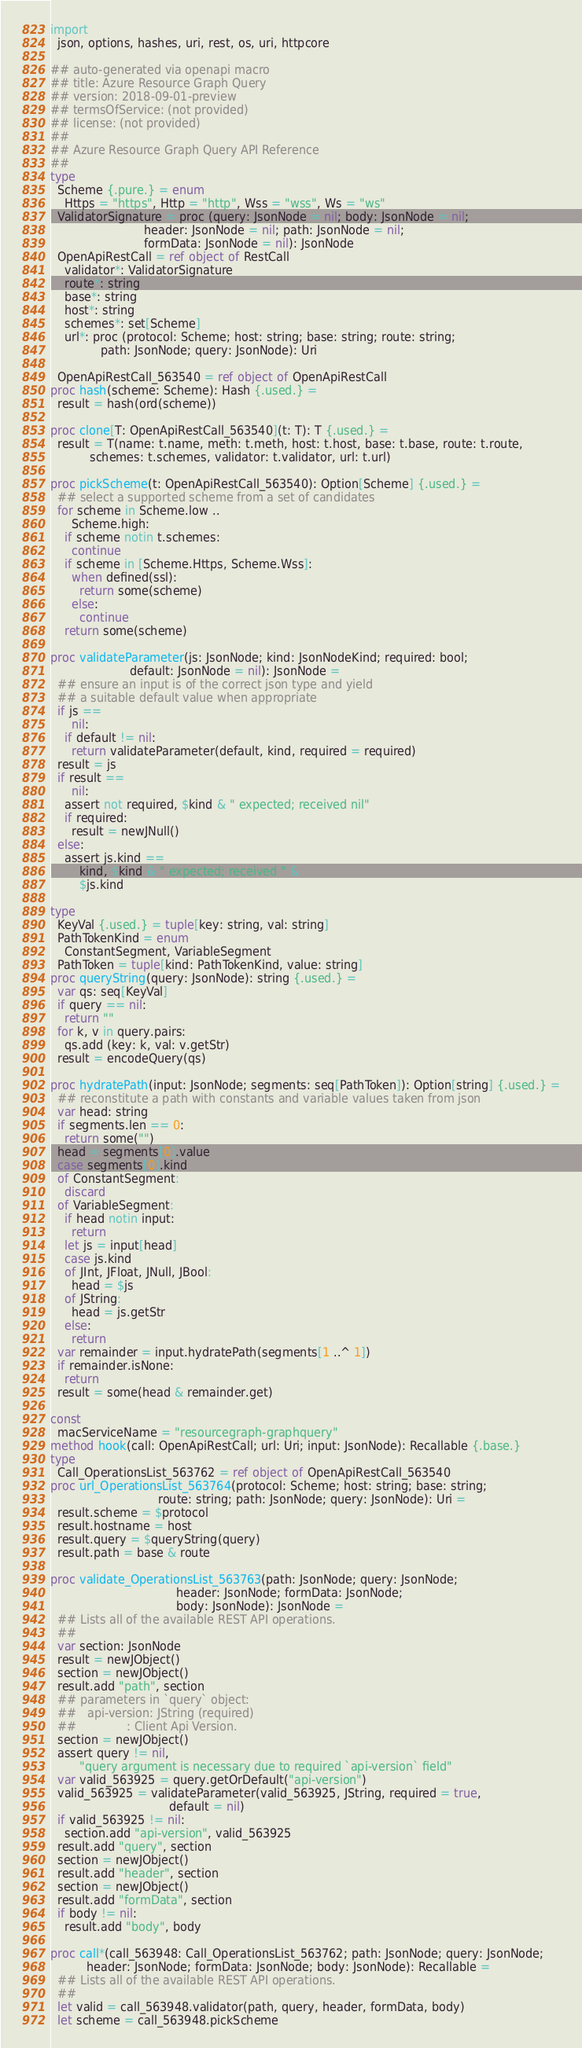<code> <loc_0><loc_0><loc_500><loc_500><_Nim_>
import
  json, options, hashes, uri, rest, os, uri, httpcore

## auto-generated via openapi macro
## title: Azure Resource Graph Query
## version: 2018-09-01-preview
## termsOfService: (not provided)
## license: (not provided)
## 
## Azure Resource Graph Query API Reference
## 
type
  Scheme {.pure.} = enum
    Https = "https", Http = "http", Wss = "wss", Ws = "ws"
  ValidatorSignature = proc (query: JsonNode = nil; body: JsonNode = nil;
                          header: JsonNode = nil; path: JsonNode = nil;
                          formData: JsonNode = nil): JsonNode
  OpenApiRestCall = ref object of RestCall
    validator*: ValidatorSignature
    route*: string
    base*: string
    host*: string
    schemes*: set[Scheme]
    url*: proc (protocol: Scheme; host: string; base: string; route: string;
              path: JsonNode; query: JsonNode): Uri

  OpenApiRestCall_563540 = ref object of OpenApiRestCall
proc hash(scheme: Scheme): Hash {.used.} =
  result = hash(ord(scheme))

proc clone[T: OpenApiRestCall_563540](t: T): T {.used.} =
  result = T(name: t.name, meth: t.meth, host: t.host, base: t.base, route: t.route,
           schemes: t.schemes, validator: t.validator, url: t.url)

proc pickScheme(t: OpenApiRestCall_563540): Option[Scheme] {.used.} =
  ## select a supported scheme from a set of candidates
  for scheme in Scheme.low ..
      Scheme.high:
    if scheme notin t.schemes:
      continue
    if scheme in [Scheme.Https, Scheme.Wss]:
      when defined(ssl):
        return some(scheme)
      else:
        continue
    return some(scheme)

proc validateParameter(js: JsonNode; kind: JsonNodeKind; required: bool;
                      default: JsonNode = nil): JsonNode =
  ## ensure an input is of the correct json type and yield
  ## a suitable default value when appropriate
  if js ==
      nil:
    if default != nil:
      return validateParameter(default, kind, required = required)
  result = js
  if result ==
      nil:
    assert not required, $kind & " expected; received nil"
    if required:
      result = newJNull()
  else:
    assert js.kind ==
        kind, $kind & " expected; received " &
        $js.kind

type
  KeyVal {.used.} = tuple[key: string, val: string]
  PathTokenKind = enum
    ConstantSegment, VariableSegment
  PathToken = tuple[kind: PathTokenKind, value: string]
proc queryString(query: JsonNode): string {.used.} =
  var qs: seq[KeyVal]
  if query == nil:
    return ""
  for k, v in query.pairs:
    qs.add (key: k, val: v.getStr)
  result = encodeQuery(qs)

proc hydratePath(input: JsonNode; segments: seq[PathToken]): Option[string] {.used.} =
  ## reconstitute a path with constants and variable values taken from json
  var head: string
  if segments.len == 0:
    return some("")
  head = segments[0].value
  case segments[0].kind
  of ConstantSegment:
    discard
  of VariableSegment:
    if head notin input:
      return
    let js = input[head]
    case js.kind
    of JInt, JFloat, JNull, JBool:
      head = $js
    of JString:
      head = js.getStr
    else:
      return
  var remainder = input.hydratePath(segments[1 ..^ 1])
  if remainder.isNone:
    return
  result = some(head & remainder.get)

const
  macServiceName = "resourcegraph-graphquery"
method hook(call: OpenApiRestCall; url: Uri; input: JsonNode): Recallable {.base.}
type
  Call_OperationsList_563762 = ref object of OpenApiRestCall_563540
proc url_OperationsList_563764(protocol: Scheme; host: string; base: string;
                              route: string; path: JsonNode; query: JsonNode): Uri =
  result.scheme = $protocol
  result.hostname = host
  result.query = $queryString(query)
  result.path = base & route

proc validate_OperationsList_563763(path: JsonNode; query: JsonNode;
                                   header: JsonNode; formData: JsonNode;
                                   body: JsonNode): JsonNode =
  ## Lists all of the available REST API operations.
  ## 
  var section: JsonNode
  result = newJObject()
  section = newJObject()
  result.add "path", section
  ## parameters in `query` object:
  ##   api-version: JString (required)
  ##              : Client Api Version.
  section = newJObject()
  assert query != nil,
        "query argument is necessary due to required `api-version` field"
  var valid_563925 = query.getOrDefault("api-version")
  valid_563925 = validateParameter(valid_563925, JString, required = true,
                                 default = nil)
  if valid_563925 != nil:
    section.add "api-version", valid_563925
  result.add "query", section
  section = newJObject()
  result.add "header", section
  section = newJObject()
  result.add "formData", section
  if body != nil:
    result.add "body", body

proc call*(call_563948: Call_OperationsList_563762; path: JsonNode; query: JsonNode;
          header: JsonNode; formData: JsonNode; body: JsonNode): Recallable =
  ## Lists all of the available REST API operations.
  ## 
  let valid = call_563948.validator(path, query, header, formData, body)
  let scheme = call_563948.pickScheme</code> 